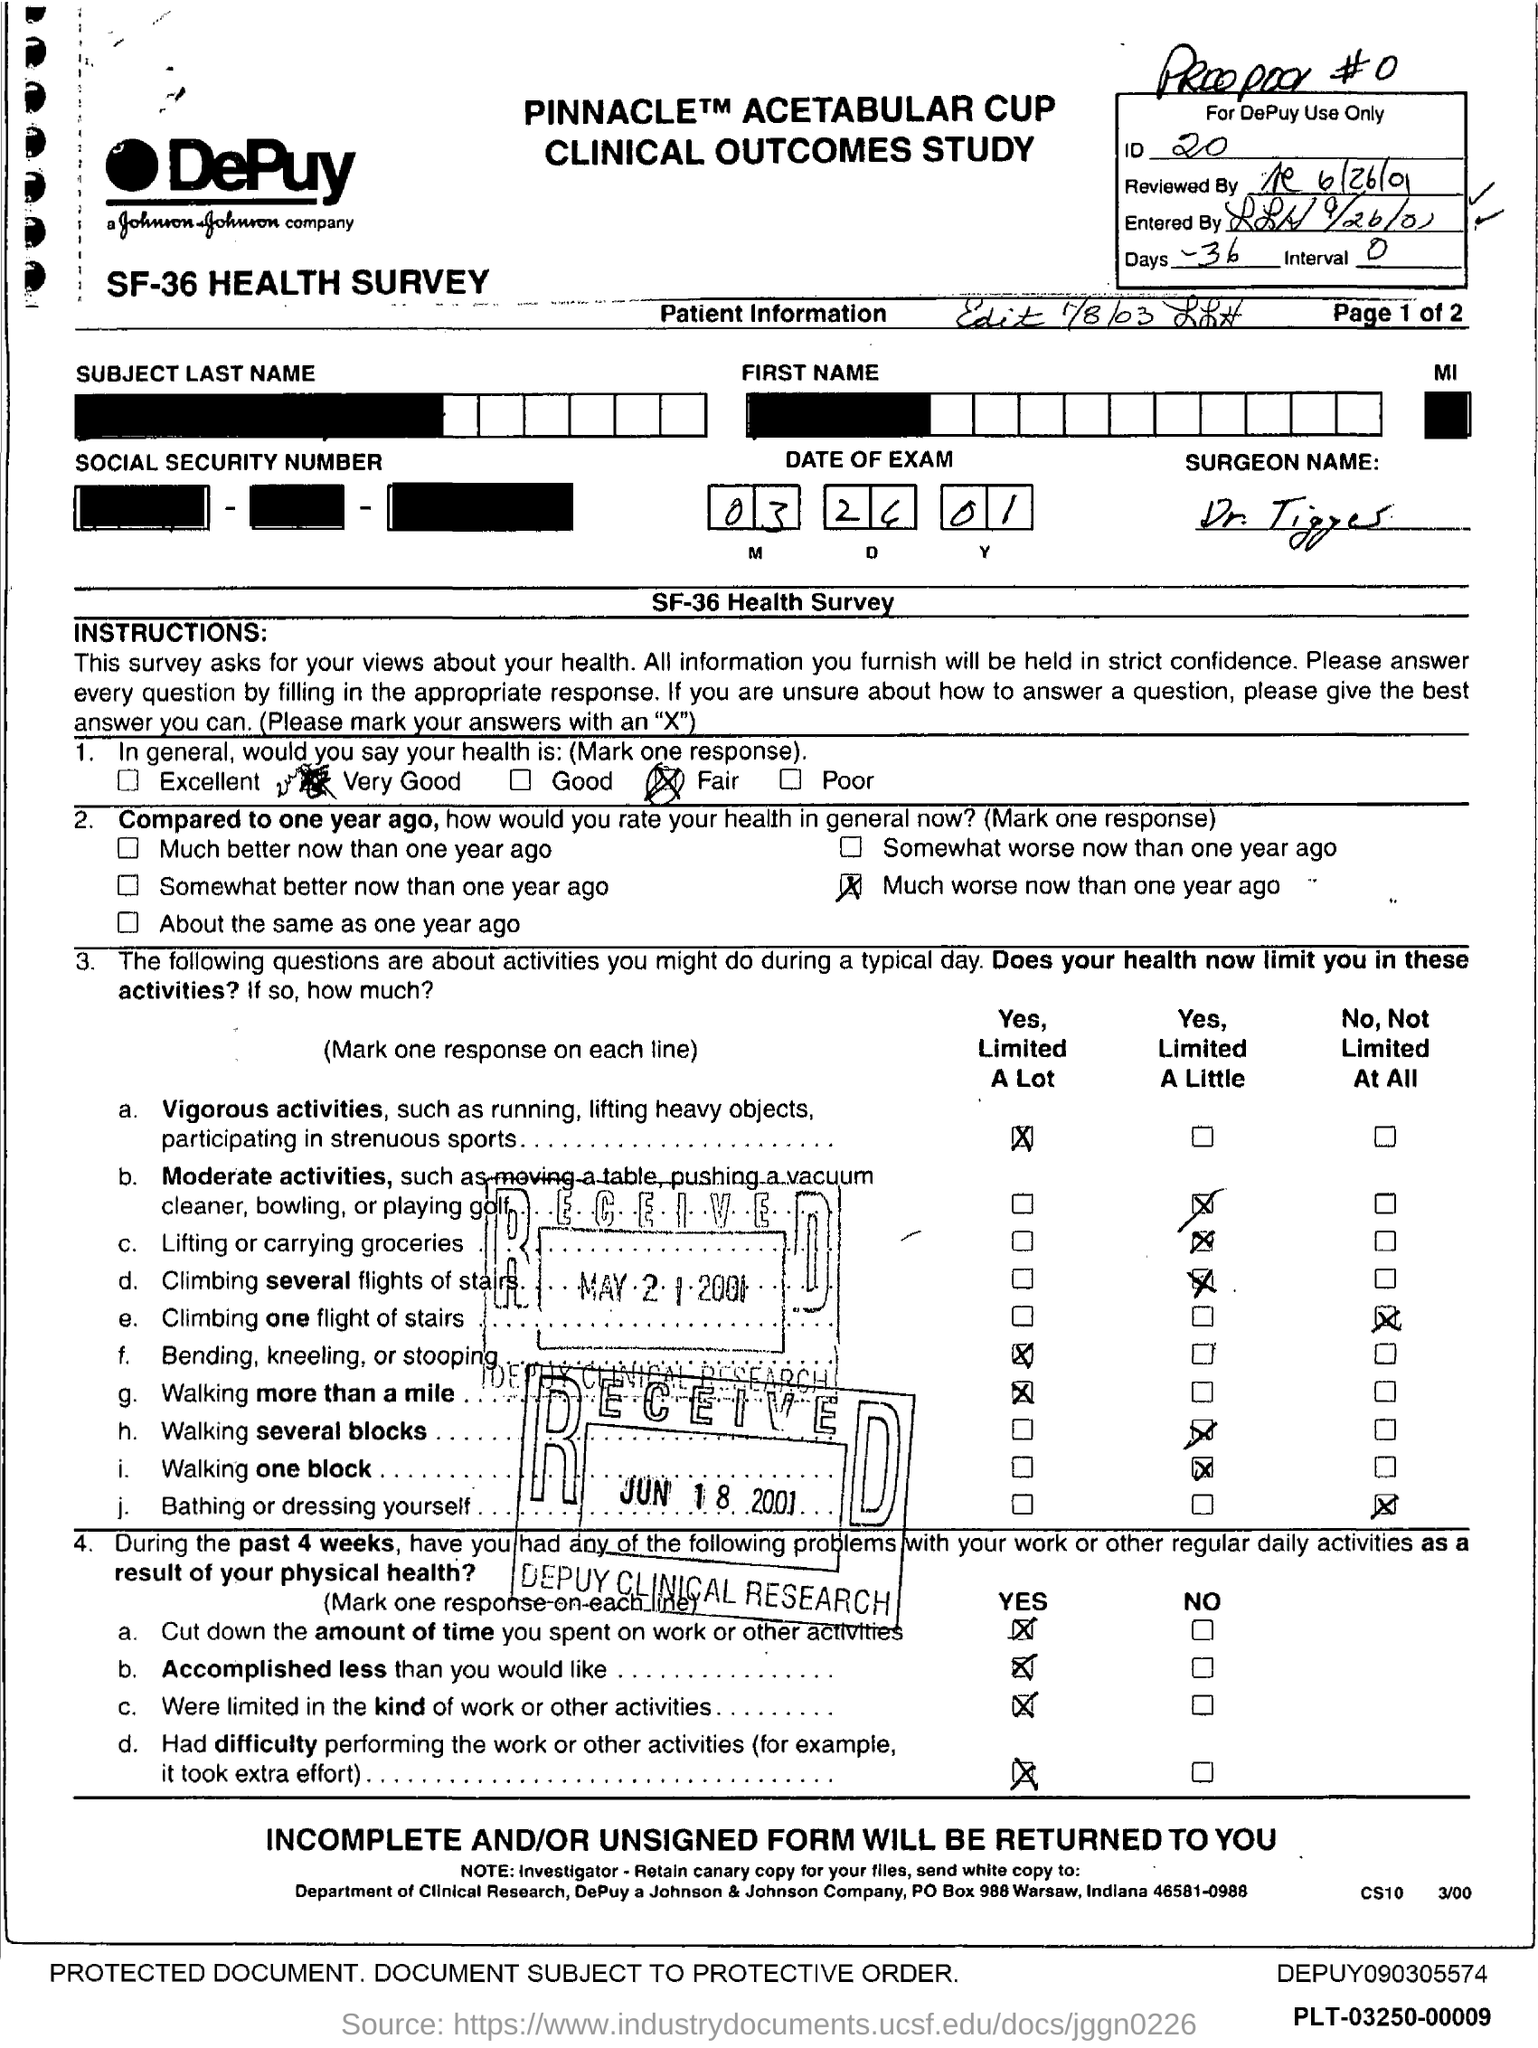What is the ID?
Keep it short and to the point. 20. What are the Days?
Keep it short and to the point. 36. What is the Interval?
Your answer should be compact. 0. 